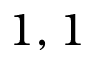Convert formula to latex. <formula><loc_0><loc_0><loc_500><loc_500>1 , 1</formula> 